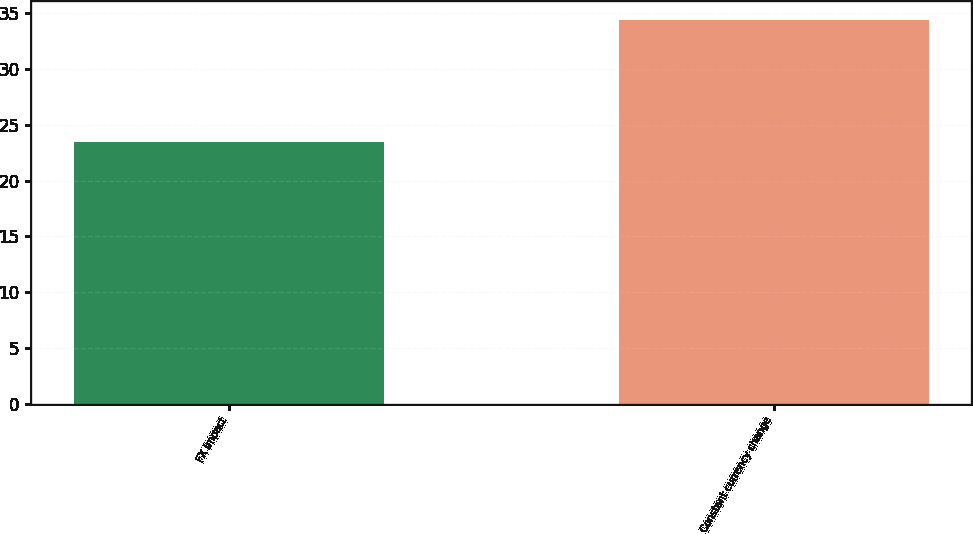Convert chart to OTSL. <chart><loc_0><loc_0><loc_500><loc_500><bar_chart><fcel>FX impact<fcel>Constant currency change<nl><fcel>23.5<fcel>34.4<nl></chart> 